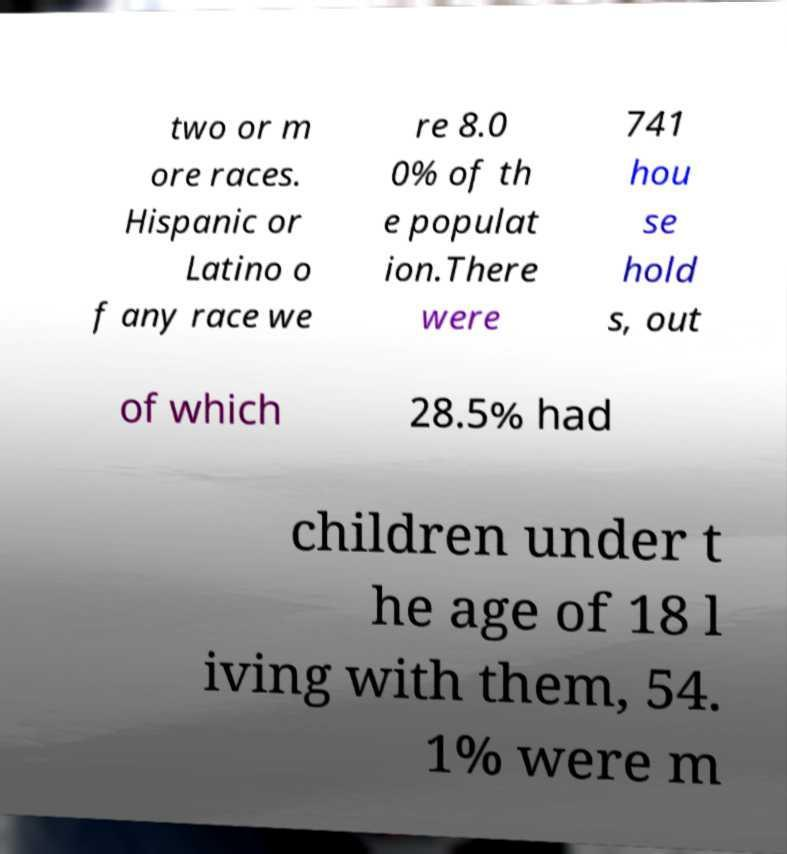What messages or text are displayed in this image? I need them in a readable, typed format. two or m ore races. Hispanic or Latino o f any race we re 8.0 0% of th e populat ion.There were 741 hou se hold s, out of which 28.5% had children under t he age of 18 l iving with them, 54. 1% were m 